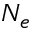Convert formula to latex. <formula><loc_0><loc_0><loc_500><loc_500>N _ { e }</formula> 